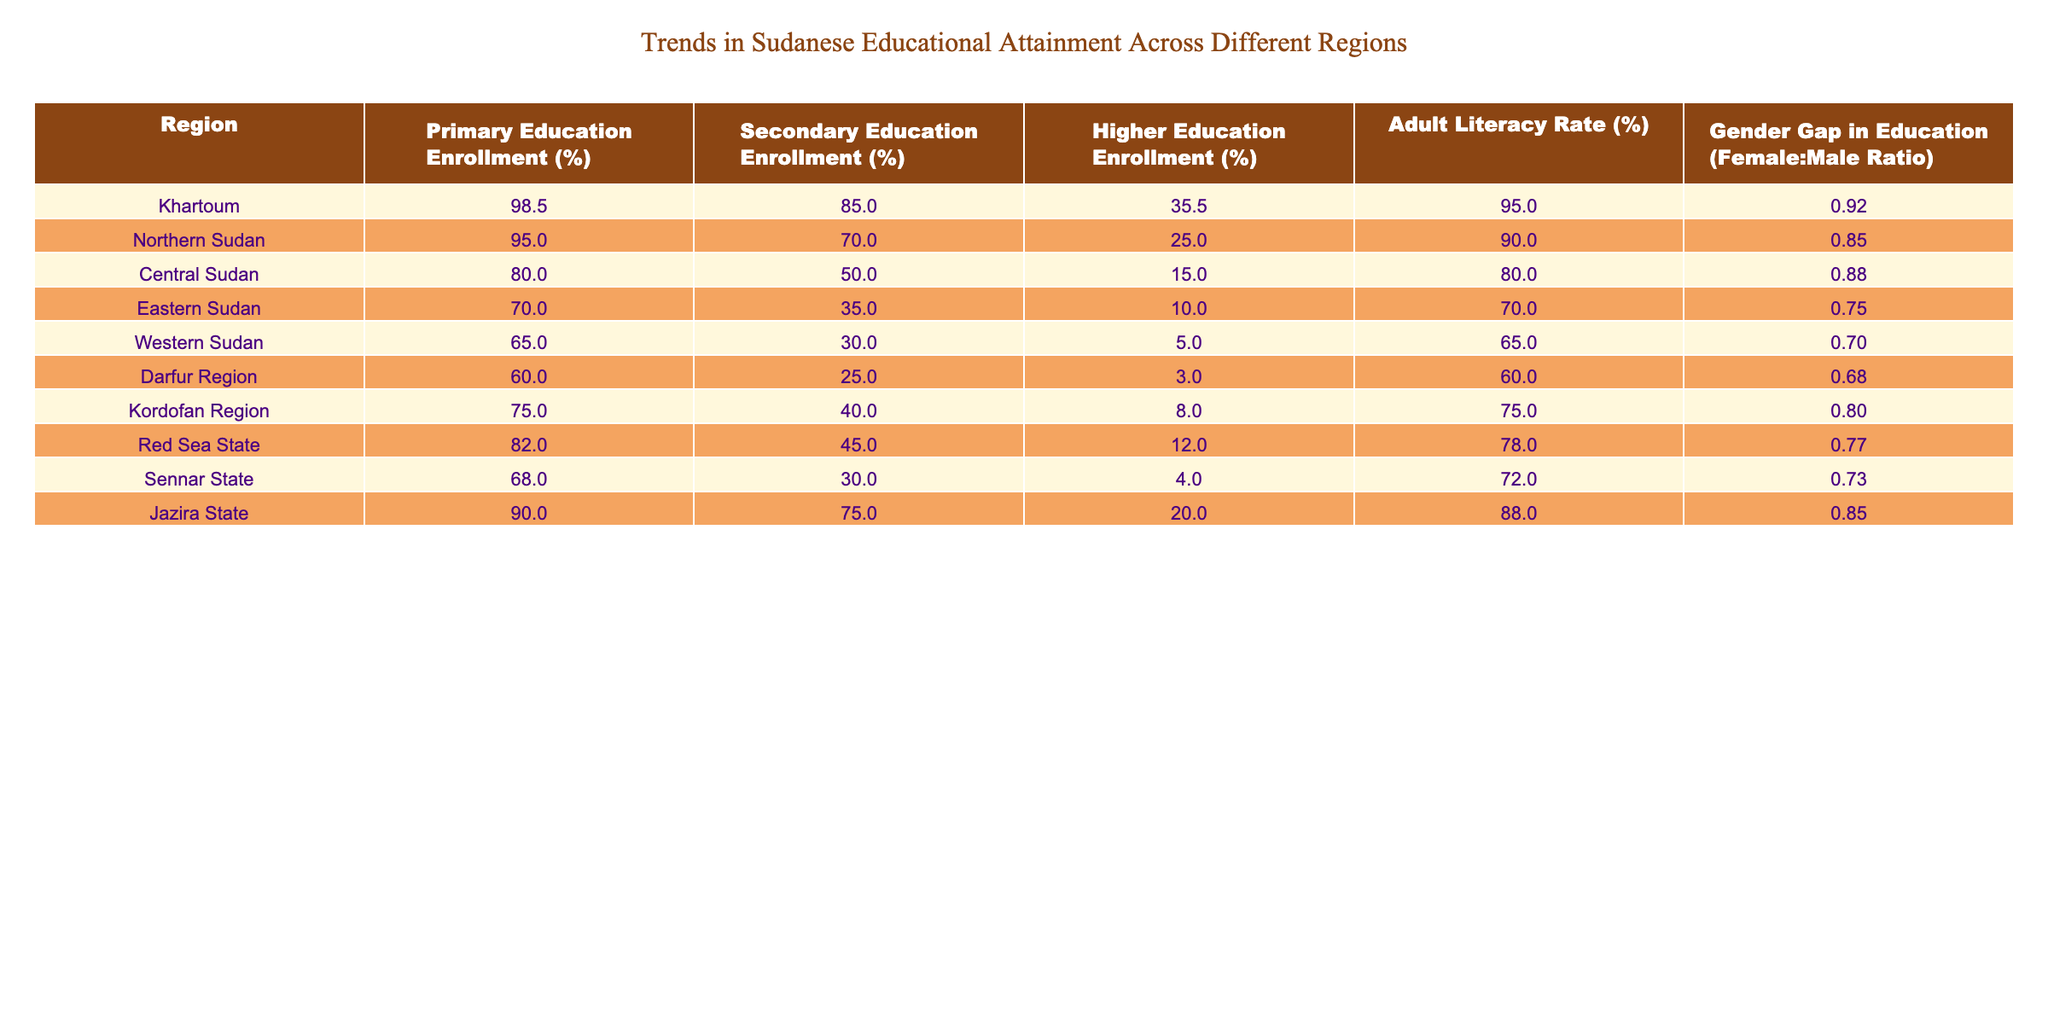What is the primary education enrollment percentage in Khartoum? From the table, the "Primary Education Enrollment (%)" for Khartoum is explicitly listed as 98.5%.
Answer: 98.5% Which region has the lowest higher education enrollment percentage? Looking at the "Higher Education Enrollment (%)" column, Darfur Region has the lowest percentage at 3%.
Answer: 3% What is the average adult literacy rate across all regions? To find the average, sum the adult literacy rates (95.0 + 90.0 + 80.0 + 70.0 + 65.0 + 60.0 + 75.0 + 78.0 + 72.0 + 88.0 = 800.0) and divide by the number of regions (10), resulting in 800.0 / 10 = 80.0%.
Answer: 80.0% Is the secondary education enrollment higher in Jazira State than in Eastern Sudan? Jazira State has a secondary education enrollment of 75%, while Eastern Sudan has 35%. Therefore, Jazira State has a higher enrollment percentage.
Answer: Yes What is the gender gap in education (female:male ratio) for Northern Sudan and how does it compare to that of Eastern Sudan? The gender gap for Northern Sudan is 0.85, whereas for Eastern Sudan it's 0.75, indicating a narrower gender gap in Northern Sudan.
Answer: 0.85 (Northern Sudan) vs 0.75 (Eastern Sudan) Which region has both the highest primary education enrollment and the highest adult literacy rate? Khartoum has the highest primary education enrollment at 98.5% and the highest adult literacy rate at 95.0%, making it the region with the best outcomes in both categories.
Answer: Khartoum If we consider the secondary education enrollment rates, which region is the second highest after Khartoum? After checking the "Secondary Education Enrollment (%)" values, Jazira State at 75% is the second highest after Khartoum's 85%.
Answer: Jazira State How does the adult literacy rate in Western Sudan compare to that in Darfur Region? The adult literacy rate in Western Sudan is 65%, while in Darfur Region, it is 60%. Thus, Western Sudan has a higher literacy rate.
Answer: 65% (Western Sudan) vs 60% (Darfur Region) What is the difference in primary education enrollment percentage between Central Sudan and Kordofan Region? Central Sudan has a primary education enrollment of 80.0%, while Kordofan Region has 75.0%. The difference is 80.0 - 75.0 = 5.0%.
Answer: 5.0% Does any region have a higher secondary education enrollment than the national average of 64%? Yes, Khartoum (85.0%), Jazira State (75.0%), and Northern Sudan (70.0%) all have higher secondary education enrollment rates than the national average.
Answer: Yes Which region shows the most significant gender gap in education based on the female:male ratio? Darfur Region has the lowest female:male ratio at 0.68, indicating the most significant gender gap in education.
Answer: 0.68 